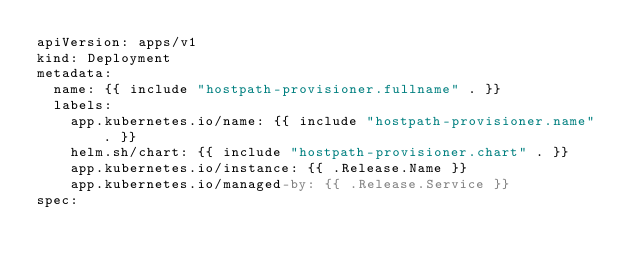Convert code to text. <code><loc_0><loc_0><loc_500><loc_500><_YAML_>apiVersion: apps/v1
kind: Deployment
metadata:
  name: {{ include "hostpath-provisioner.fullname" . }}
  labels:
    app.kubernetes.io/name: {{ include "hostpath-provisioner.name" . }}
    helm.sh/chart: {{ include "hostpath-provisioner.chart" . }}
    app.kubernetes.io/instance: {{ .Release.Name }}
    app.kubernetes.io/managed-by: {{ .Release.Service }}
spec:</code> 